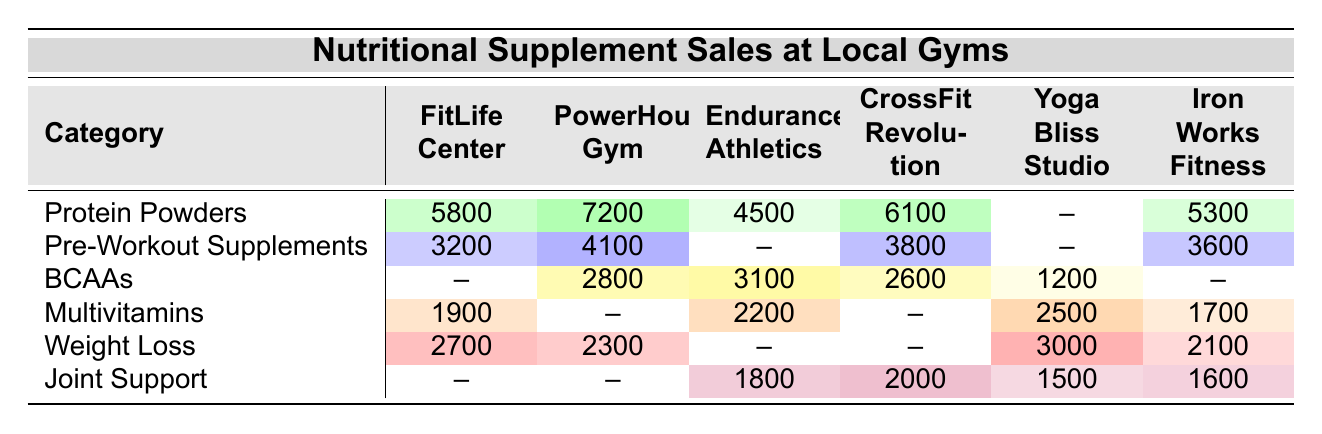What is the total sales for Protein Powders at all gyms? To find the total sales for Protein Powders, identify the sales figures for each gym listed in the category: FitLife Center (5800), PowerHouse Gym (7200), Endurance Athletics (4500), CrossFit Revolution (6100), and Iron Works Fitness (5300). Adding these amounts gives: 5800 + 7200 + 4500 + 6100 + 5300 = 28900.
Answer: 28900 Which gym has the highest sales for BCAAs? Looking at the BCAAs row, the sales figures for each gym are: PowerHouse Gym (2800), Endurance Athletics (3100), CrossFit Revolution (2600), and Yoga Bliss Studio (1200). The highest value is 3100 from Endurance Athletics.
Answer: Endurance Athletics Did Yoga Bliss Studio make any sales in Joint Support? In the Joint Support row, the sales amount for Yoga Bliss Studio is listed as 1500, indicating that they did make sales in this category.
Answer: Yes What is the difference in sales between the highest and lowest category for Weight Loss? The highest sales for Weight Loss is at Yoga Bliss Studio (3000) and the lowest is at FitLife Center (2700). The difference is calculated as: 3000 - 2700 = 300.
Answer: 300 Which gym sells the most Pre-Workout Supplements? The sales amounts for Pre-Workout Supplements are: FitLife Center (3200), PowerHouse Gym (4100), CrossFit Revolution (3800), and Iron Works Fitness (3600). The highest is 4100 from PowerHouse Gym.
Answer: PowerHouse Gym What is the average sales amount for Multivitamins across all gyms that sold them? The gyms that sold Multivitamins and their sales amounts are: FitLife Center (1900), Endurance Athletics (2200), Yoga Bliss Studio (2500), and Iron Works Fitness (1700). This results in: (1900 + 2200 + 2500 + 1700) = 8300. The average is 8300 divided by 4, which equals 2075.
Answer: 2075 How many categories have sales recorded for Iron Works Fitness? By examining the Iron Works Fitness column, the categories with recorded sales are: Protein Powders (5300), Pre-Workout Supplements (3600), Multivitamins (1700), Weight Loss (2100), and Joint Support (1600). This totals to 5 categories.
Answer: 5 Which category had no sales at FitLife Center? Looking at the table, FitLife Center shows sales for Protein Powders, Pre-Workout Supplements, Multivitamins, Weight Loss, and does not show any sales recorded for BCAAs.
Answer: BCAAs What percentage of total sales in the Protein Powders category comes from PowerHouse Gym? PowerHouse Gym's sales for Protein Powders is 7200, and total sales for Protein Powders is 28900. The percentage is calculated as: (7200 / 28900) * 100 = approximately 24.9%.
Answer: 24.9% Which gym has the least sales for Weight Loss? The sales figures for Weight Loss are as follows: FitLife Center (2700), PowerHouse Gym (2300), Yoga Bliss Studio (3000), and Iron Works Fitness (2100). The least sales are at Iron Works Fitness with 2100.
Answer: Iron Works Fitness 